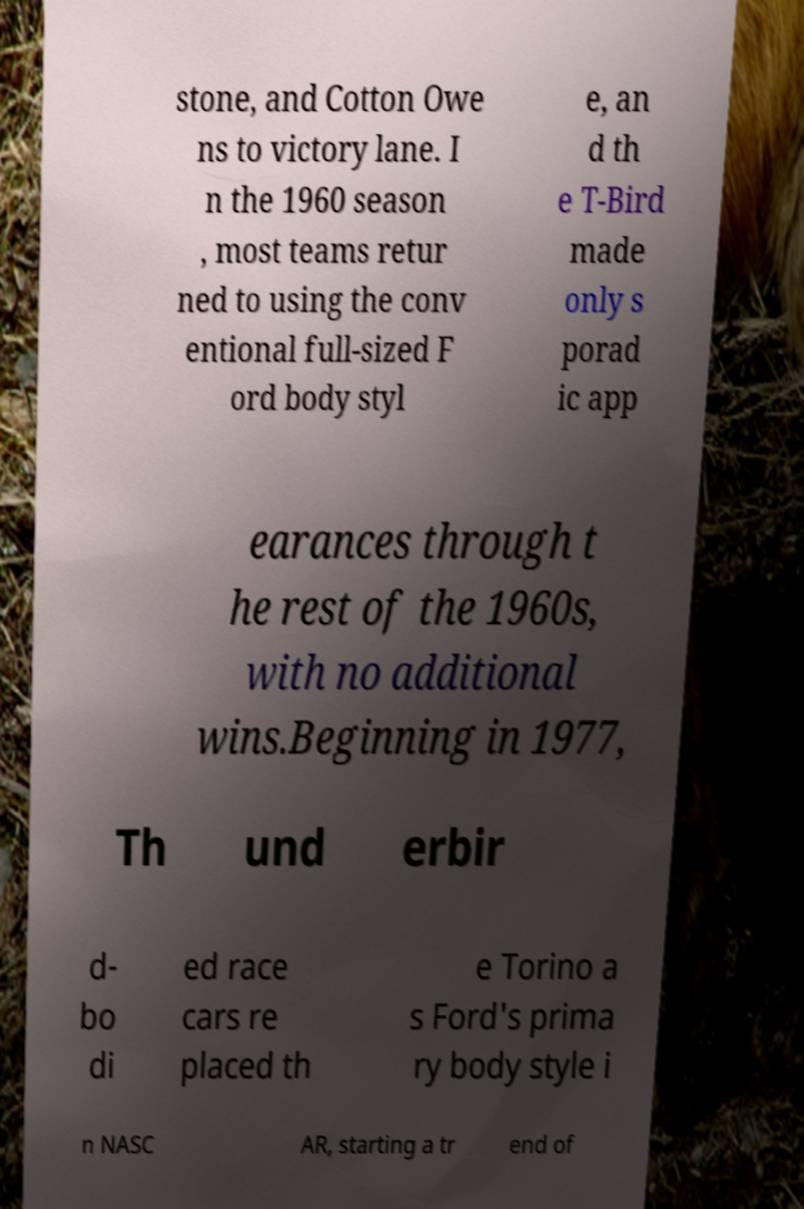There's text embedded in this image that I need extracted. Can you transcribe it verbatim? stone, and Cotton Owe ns to victory lane. I n the 1960 season , most teams retur ned to using the conv entional full-sized F ord body styl e, an d th e T-Bird made only s porad ic app earances through t he rest of the 1960s, with no additional wins.Beginning in 1977, Th und erbir d- bo di ed race cars re placed th e Torino a s Ford's prima ry body style i n NASC AR, starting a tr end of 